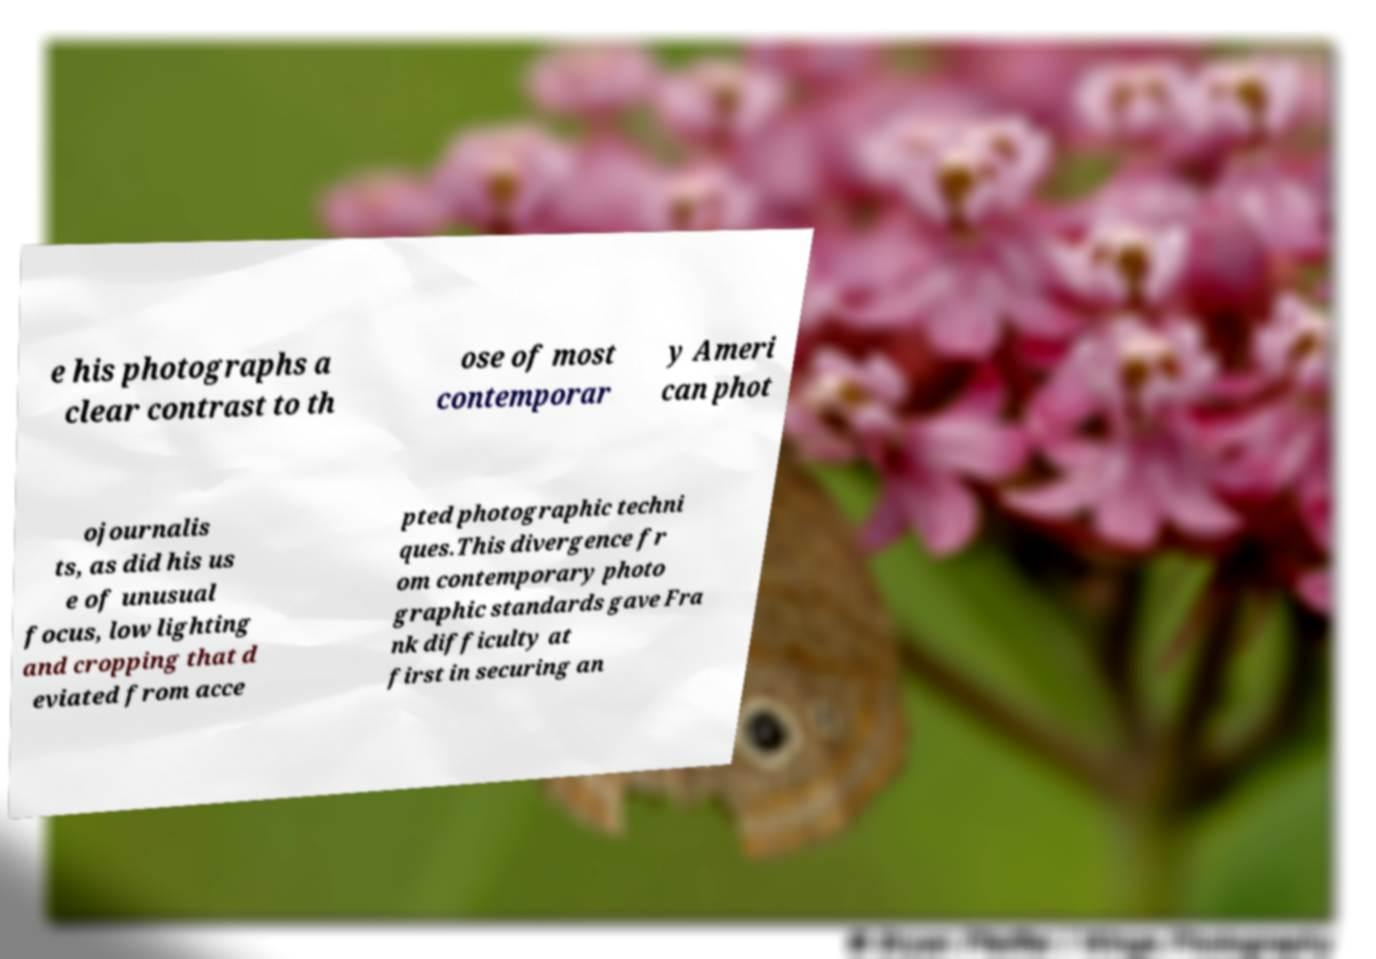There's text embedded in this image that I need extracted. Can you transcribe it verbatim? e his photographs a clear contrast to th ose of most contemporar y Ameri can phot ojournalis ts, as did his us e of unusual focus, low lighting and cropping that d eviated from acce pted photographic techni ques.This divergence fr om contemporary photo graphic standards gave Fra nk difficulty at first in securing an 